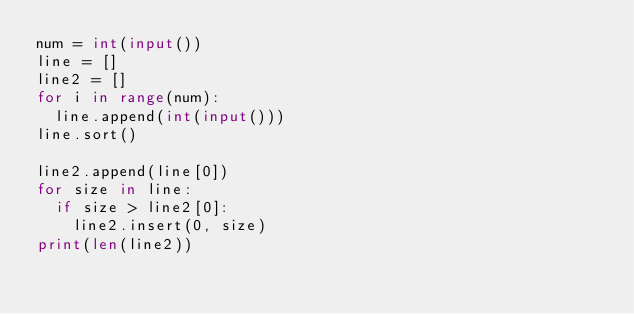Convert code to text. <code><loc_0><loc_0><loc_500><loc_500><_Python_>num = int(input())
line = []
line2 = []
for i in range(num):
  line.append(int(input()))
line.sort()

line2.append(line[0])
for size in line:
  if size > line2[0]:
    line2.insert(0, size)
print(len(line2))</code> 